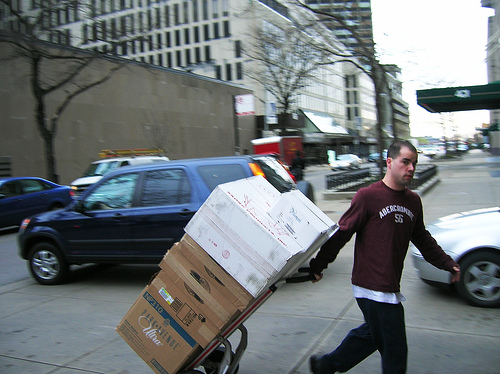<image>
Is there a man in front of the car? Yes. The man is positioned in front of the car, appearing closer to the camera viewpoint. 